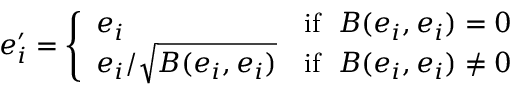Convert formula to latex. <formula><loc_0><loc_0><loc_500><loc_500>e _ { i } ^ { \prime } = { \left \{ \begin{array} { l l } { e _ { i } } & { { i f } \, B ( e _ { i } , e _ { i } ) = 0 } \\ { e _ { i } / { \sqrt { B ( e _ { i } , e _ { i } ) } } } & { { i f } \, B ( e _ { i } , e _ { i } ) \neq 0 } \end{array} }</formula> 